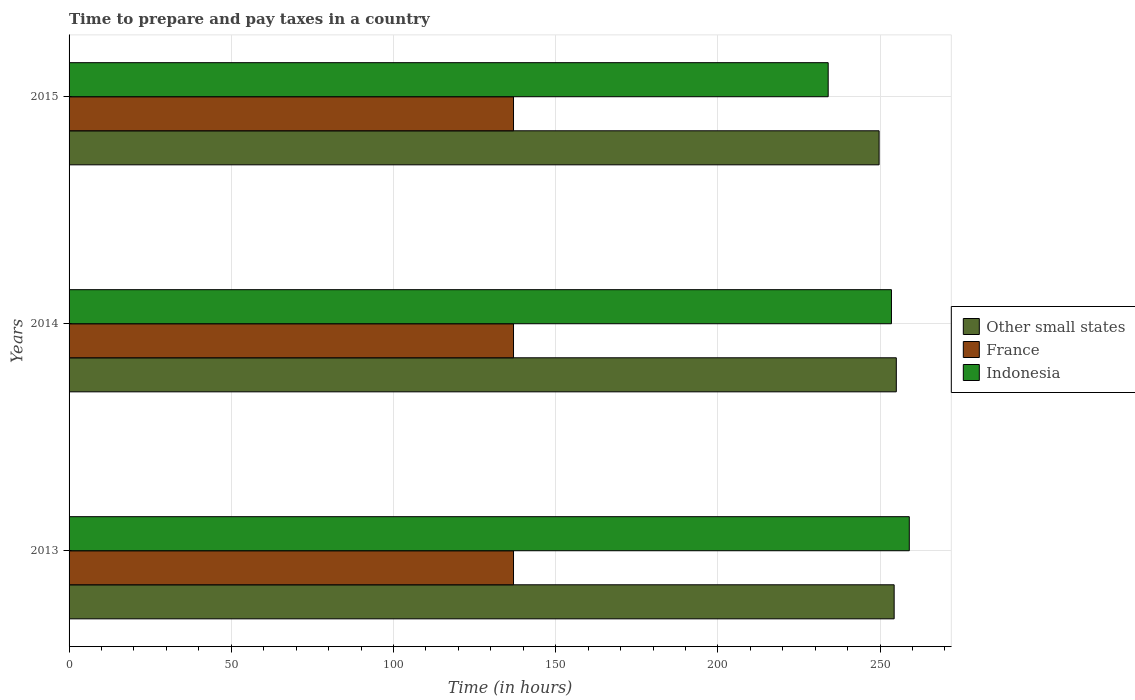How many different coloured bars are there?
Give a very brief answer. 3. What is the label of the 1st group of bars from the top?
Your response must be concise. 2015. What is the number of hours required to prepare and pay taxes in France in 2015?
Offer a very short reply. 137. Across all years, what is the maximum number of hours required to prepare and pay taxes in France?
Offer a very short reply. 137. Across all years, what is the minimum number of hours required to prepare and pay taxes in France?
Give a very brief answer. 137. In which year was the number of hours required to prepare and pay taxes in Other small states minimum?
Keep it short and to the point. 2015. What is the total number of hours required to prepare and pay taxes in France in the graph?
Provide a succinct answer. 411. What is the difference between the number of hours required to prepare and pay taxes in Indonesia in 2013 and that in 2015?
Offer a terse response. 25. What is the difference between the number of hours required to prepare and pay taxes in France in 2014 and the number of hours required to prepare and pay taxes in Other small states in 2013?
Keep it short and to the point. -117.33. What is the average number of hours required to prepare and pay taxes in France per year?
Offer a terse response. 137. In the year 2014, what is the difference between the number of hours required to prepare and pay taxes in France and number of hours required to prepare and pay taxes in Other small states?
Make the answer very short. -118. In how many years, is the number of hours required to prepare and pay taxes in Indonesia greater than 170 hours?
Make the answer very short. 3. What is the ratio of the number of hours required to prepare and pay taxes in Other small states in 2013 to that in 2014?
Your answer should be very brief. 1. Is the number of hours required to prepare and pay taxes in Other small states in 2013 less than that in 2014?
Offer a terse response. Yes. Is the difference between the number of hours required to prepare and pay taxes in France in 2014 and 2015 greater than the difference between the number of hours required to prepare and pay taxes in Other small states in 2014 and 2015?
Give a very brief answer. No. What is the difference between the highest and the second highest number of hours required to prepare and pay taxes in Other small states?
Offer a terse response. 0.67. What is the difference between the highest and the lowest number of hours required to prepare and pay taxes in Indonesia?
Your answer should be compact. 25. In how many years, is the number of hours required to prepare and pay taxes in Indonesia greater than the average number of hours required to prepare and pay taxes in Indonesia taken over all years?
Your response must be concise. 2. Is the sum of the number of hours required to prepare and pay taxes in France in 2013 and 2015 greater than the maximum number of hours required to prepare and pay taxes in Indonesia across all years?
Your answer should be compact. Yes. What does the 2nd bar from the top in 2014 represents?
Provide a succinct answer. France. What does the 2nd bar from the bottom in 2014 represents?
Your answer should be compact. France. Is it the case that in every year, the sum of the number of hours required to prepare and pay taxes in Other small states and number of hours required to prepare and pay taxes in France is greater than the number of hours required to prepare and pay taxes in Indonesia?
Offer a very short reply. Yes. How many bars are there?
Provide a succinct answer. 9. Are all the bars in the graph horizontal?
Offer a very short reply. Yes. How many years are there in the graph?
Your answer should be very brief. 3. Does the graph contain grids?
Offer a very short reply. Yes. Where does the legend appear in the graph?
Provide a succinct answer. Center right. How are the legend labels stacked?
Give a very brief answer. Vertical. What is the title of the graph?
Give a very brief answer. Time to prepare and pay taxes in a country. Does "North America" appear as one of the legend labels in the graph?
Offer a very short reply. No. What is the label or title of the X-axis?
Your response must be concise. Time (in hours). What is the Time (in hours) of Other small states in 2013?
Your answer should be very brief. 254.33. What is the Time (in hours) of France in 2013?
Provide a short and direct response. 137. What is the Time (in hours) in Indonesia in 2013?
Your answer should be compact. 259. What is the Time (in hours) of Other small states in 2014?
Make the answer very short. 255. What is the Time (in hours) of France in 2014?
Provide a succinct answer. 137. What is the Time (in hours) of Indonesia in 2014?
Your response must be concise. 253.5. What is the Time (in hours) of Other small states in 2015?
Provide a short and direct response. 249.69. What is the Time (in hours) in France in 2015?
Offer a terse response. 137. What is the Time (in hours) of Indonesia in 2015?
Your answer should be very brief. 234. Across all years, what is the maximum Time (in hours) of Other small states?
Provide a short and direct response. 255. Across all years, what is the maximum Time (in hours) of France?
Ensure brevity in your answer.  137. Across all years, what is the maximum Time (in hours) in Indonesia?
Offer a very short reply. 259. Across all years, what is the minimum Time (in hours) in Other small states?
Offer a very short reply. 249.69. Across all years, what is the minimum Time (in hours) of France?
Give a very brief answer. 137. Across all years, what is the minimum Time (in hours) in Indonesia?
Offer a terse response. 234. What is the total Time (in hours) of Other small states in the graph?
Provide a succinct answer. 759.03. What is the total Time (in hours) in France in the graph?
Your answer should be compact. 411. What is the total Time (in hours) of Indonesia in the graph?
Give a very brief answer. 746.5. What is the difference between the Time (in hours) in Other small states in 2013 and that in 2014?
Offer a terse response. -0.67. What is the difference between the Time (in hours) of France in 2013 and that in 2014?
Ensure brevity in your answer.  0. What is the difference between the Time (in hours) of Indonesia in 2013 and that in 2014?
Provide a succinct answer. 5.5. What is the difference between the Time (in hours) of Other small states in 2013 and that in 2015?
Offer a terse response. 4.64. What is the difference between the Time (in hours) in Indonesia in 2013 and that in 2015?
Your answer should be very brief. 25. What is the difference between the Time (in hours) in Other small states in 2014 and that in 2015?
Your response must be concise. 5.31. What is the difference between the Time (in hours) of Indonesia in 2014 and that in 2015?
Your answer should be very brief. 19.5. What is the difference between the Time (in hours) of Other small states in 2013 and the Time (in hours) of France in 2014?
Your answer should be compact. 117.33. What is the difference between the Time (in hours) in Other small states in 2013 and the Time (in hours) in Indonesia in 2014?
Offer a very short reply. 0.83. What is the difference between the Time (in hours) in France in 2013 and the Time (in hours) in Indonesia in 2014?
Ensure brevity in your answer.  -116.5. What is the difference between the Time (in hours) in Other small states in 2013 and the Time (in hours) in France in 2015?
Provide a short and direct response. 117.33. What is the difference between the Time (in hours) of Other small states in 2013 and the Time (in hours) of Indonesia in 2015?
Offer a terse response. 20.33. What is the difference between the Time (in hours) of France in 2013 and the Time (in hours) of Indonesia in 2015?
Ensure brevity in your answer.  -97. What is the difference between the Time (in hours) of Other small states in 2014 and the Time (in hours) of France in 2015?
Give a very brief answer. 118. What is the difference between the Time (in hours) in Other small states in 2014 and the Time (in hours) in Indonesia in 2015?
Provide a succinct answer. 21. What is the difference between the Time (in hours) of France in 2014 and the Time (in hours) of Indonesia in 2015?
Keep it short and to the point. -97. What is the average Time (in hours) in Other small states per year?
Make the answer very short. 253.01. What is the average Time (in hours) in France per year?
Provide a succinct answer. 137. What is the average Time (in hours) of Indonesia per year?
Your response must be concise. 248.83. In the year 2013, what is the difference between the Time (in hours) of Other small states and Time (in hours) of France?
Give a very brief answer. 117.33. In the year 2013, what is the difference between the Time (in hours) of Other small states and Time (in hours) of Indonesia?
Your answer should be compact. -4.67. In the year 2013, what is the difference between the Time (in hours) of France and Time (in hours) of Indonesia?
Your answer should be very brief. -122. In the year 2014, what is the difference between the Time (in hours) in Other small states and Time (in hours) in France?
Your response must be concise. 118. In the year 2014, what is the difference between the Time (in hours) in France and Time (in hours) in Indonesia?
Make the answer very short. -116.5. In the year 2015, what is the difference between the Time (in hours) of Other small states and Time (in hours) of France?
Keep it short and to the point. 112.69. In the year 2015, what is the difference between the Time (in hours) in Other small states and Time (in hours) in Indonesia?
Offer a very short reply. 15.69. In the year 2015, what is the difference between the Time (in hours) in France and Time (in hours) in Indonesia?
Give a very brief answer. -97. What is the ratio of the Time (in hours) in Other small states in 2013 to that in 2014?
Give a very brief answer. 1. What is the ratio of the Time (in hours) in Indonesia in 2013 to that in 2014?
Make the answer very short. 1.02. What is the ratio of the Time (in hours) in Other small states in 2013 to that in 2015?
Your answer should be very brief. 1.02. What is the ratio of the Time (in hours) in Indonesia in 2013 to that in 2015?
Ensure brevity in your answer.  1.11. What is the ratio of the Time (in hours) of Other small states in 2014 to that in 2015?
Provide a succinct answer. 1.02. What is the ratio of the Time (in hours) in Indonesia in 2014 to that in 2015?
Ensure brevity in your answer.  1.08. What is the difference between the highest and the second highest Time (in hours) in Indonesia?
Give a very brief answer. 5.5. What is the difference between the highest and the lowest Time (in hours) of Other small states?
Ensure brevity in your answer.  5.31. 